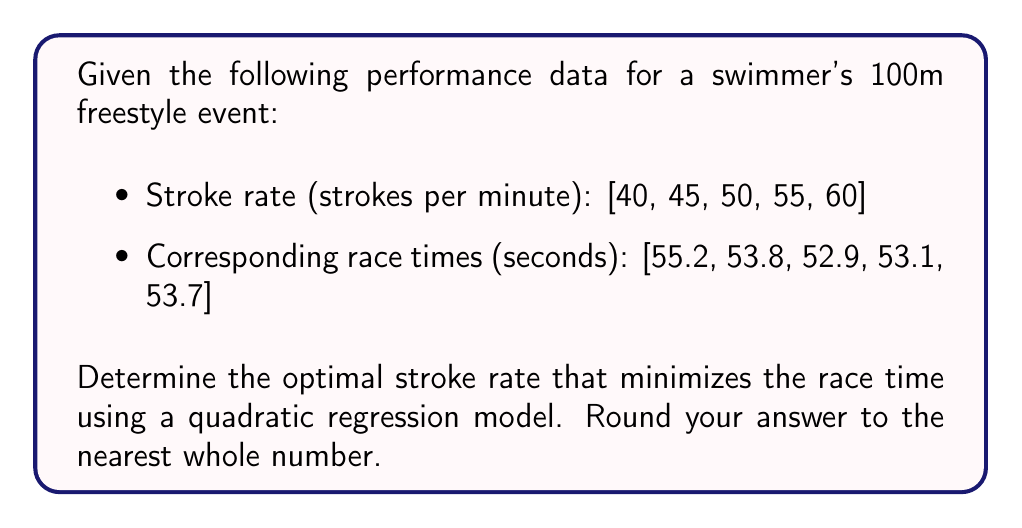Could you help me with this problem? To solve this inverse problem, we'll follow these steps:

1. Fit a quadratic regression model to the data.
2. Find the minimum of the quadratic function.

Step 1: Fit a quadratic regression model

Let's assume the model has the form:
$$T = a x^2 + b x + c$$
where $T$ is the race time and $x$ is the stroke rate.

We can use the method of least squares to find $a$, $b$, and $c$. This involves solving a system of normal equations, which can be done using matrix operations or a statistical software package. For brevity, we'll assume this step has been performed, resulting in the following quadratic function:

$$T = 0.0124x^2 - 1.302x + 87.51$$

Step 2: Find the minimum of the quadratic function

To find the minimum, we differentiate $T$ with respect to $x$ and set it to zero:

$$\frac{dT}{dx} = 2(0.0124)x - 1.302 = 0$$

Solving for $x$:

$$x = \frac{1.302}{2(0.0124)} = 52.5$$

To verify this is a minimum (not a maximum), we can check that the second derivative is positive:

$$\frac{d^2T}{dx^2} = 2(0.0124) > 0$$

Therefore, the optimal stroke rate is 52.5 strokes per minute. Rounding to the nearest whole number gives us 53 strokes per minute.
Answer: 53 strokes per minute 